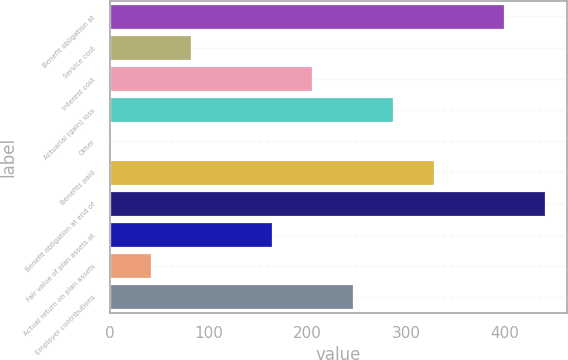Convert chart to OTSL. <chart><loc_0><loc_0><loc_500><loc_500><bar_chart><fcel>Benefit obligation at<fcel>Service cost<fcel>Interest cost<fcel>Actuarial (gain) loss<fcel>Other<fcel>Benefits paid<fcel>Benefit obligation at end of<fcel>Fair value of plan assets at<fcel>Actual return on plan assets<fcel>Employer contributions<nl><fcel>399.6<fcel>82.1<fcel>205.1<fcel>287.1<fcel>0.1<fcel>328.1<fcel>440.6<fcel>164.1<fcel>41.1<fcel>246.1<nl></chart> 